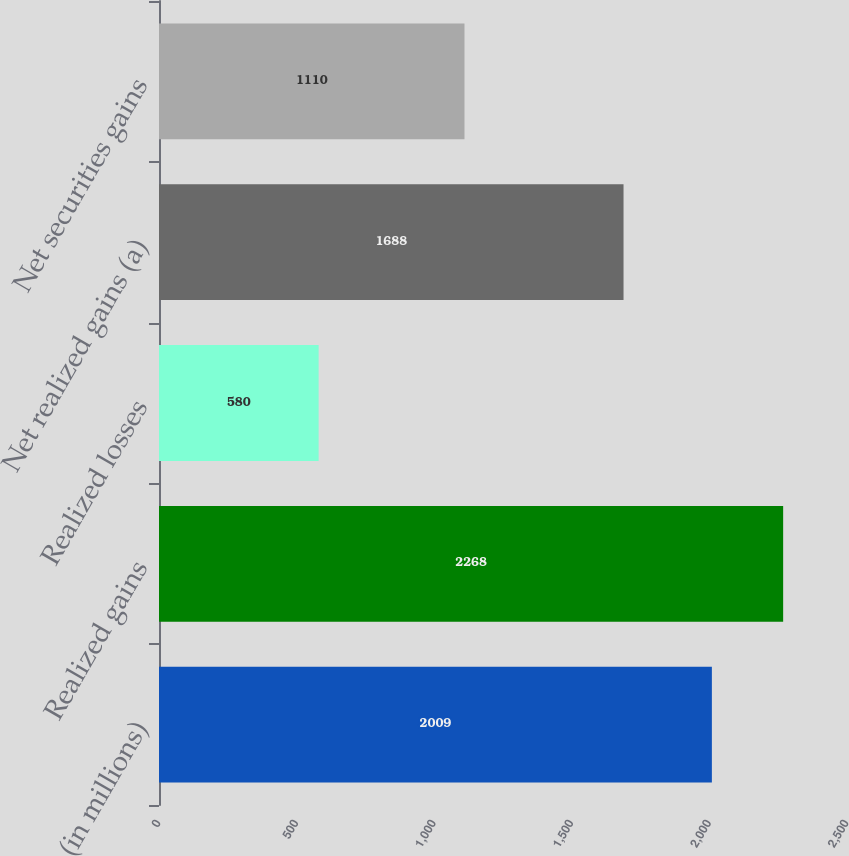<chart> <loc_0><loc_0><loc_500><loc_500><bar_chart><fcel>(in millions)<fcel>Realized gains<fcel>Realized losses<fcel>Net realized gains (a)<fcel>Net securities gains<nl><fcel>2009<fcel>2268<fcel>580<fcel>1688<fcel>1110<nl></chart> 